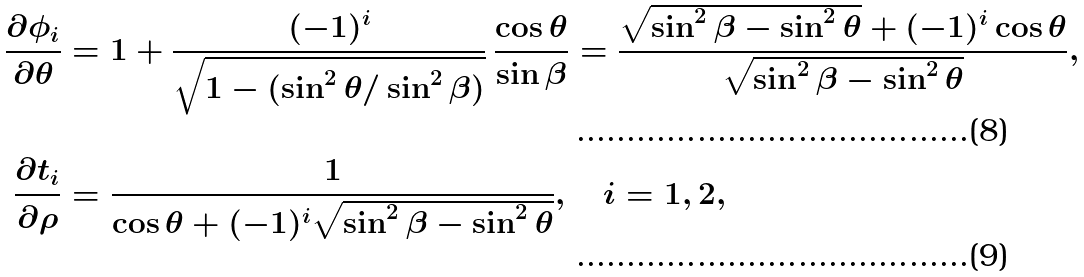<formula> <loc_0><loc_0><loc_500><loc_500>\frac { \partial \phi _ { i } } { \partial \theta } & = 1 + \frac { ( - 1 ) ^ { i } } { \sqrt { 1 - ( \sin ^ { 2 } \theta / \sin ^ { 2 } \beta ) } } \, \frac { \cos \theta } { \sin \beta } = \frac { \sqrt { \sin ^ { 2 } \beta - \sin ^ { 2 } \theta } + ( - 1 ) ^ { i } \cos \theta } { \sqrt { \sin ^ { 2 } \beta - \sin ^ { 2 } \theta } } , \\ \frac { \partial t _ { i } } { \partial \rho } & = \frac { 1 } { \cos \theta + ( - 1 ) ^ { i } \sqrt { \sin ^ { 2 } \beta - \sin ^ { 2 } \theta } } , \quad i = 1 , 2 ,</formula> 